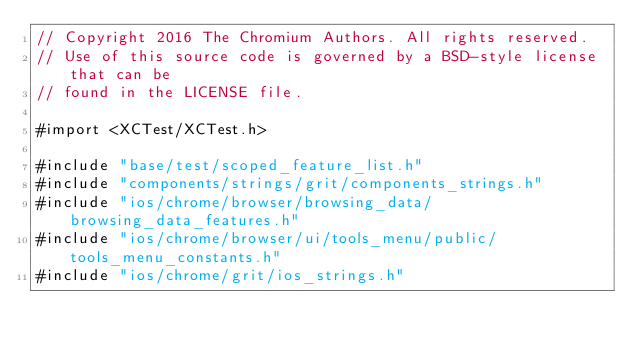<code> <loc_0><loc_0><loc_500><loc_500><_ObjectiveC_>// Copyright 2016 The Chromium Authors. All rights reserved.
// Use of this source code is governed by a BSD-style license that can be
// found in the LICENSE file.

#import <XCTest/XCTest.h>

#include "base/test/scoped_feature_list.h"
#include "components/strings/grit/components_strings.h"
#include "ios/chrome/browser/browsing_data/browsing_data_features.h"
#include "ios/chrome/browser/ui/tools_menu/public/tools_menu_constants.h"
#include "ios/chrome/grit/ios_strings.h"</code> 